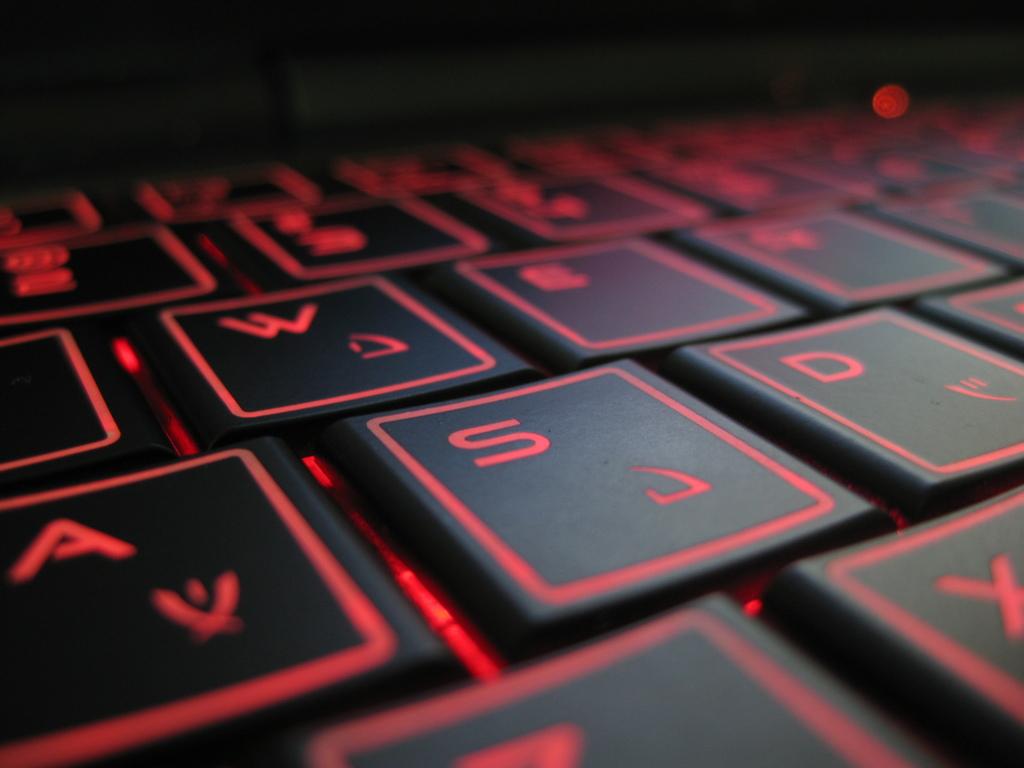What is the letter to the right of s?
Ensure brevity in your answer.  D. What is the left most letter?
Ensure brevity in your answer.  A. 